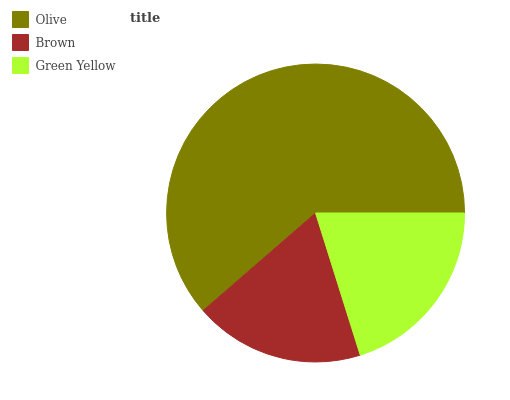Is Brown the minimum?
Answer yes or no. Yes. Is Olive the maximum?
Answer yes or no. Yes. Is Green Yellow the minimum?
Answer yes or no. No. Is Green Yellow the maximum?
Answer yes or no. No. Is Green Yellow greater than Brown?
Answer yes or no. Yes. Is Brown less than Green Yellow?
Answer yes or no. Yes. Is Brown greater than Green Yellow?
Answer yes or no. No. Is Green Yellow less than Brown?
Answer yes or no. No. Is Green Yellow the high median?
Answer yes or no. Yes. Is Green Yellow the low median?
Answer yes or no. Yes. Is Brown the high median?
Answer yes or no. No. Is Brown the low median?
Answer yes or no. No. 